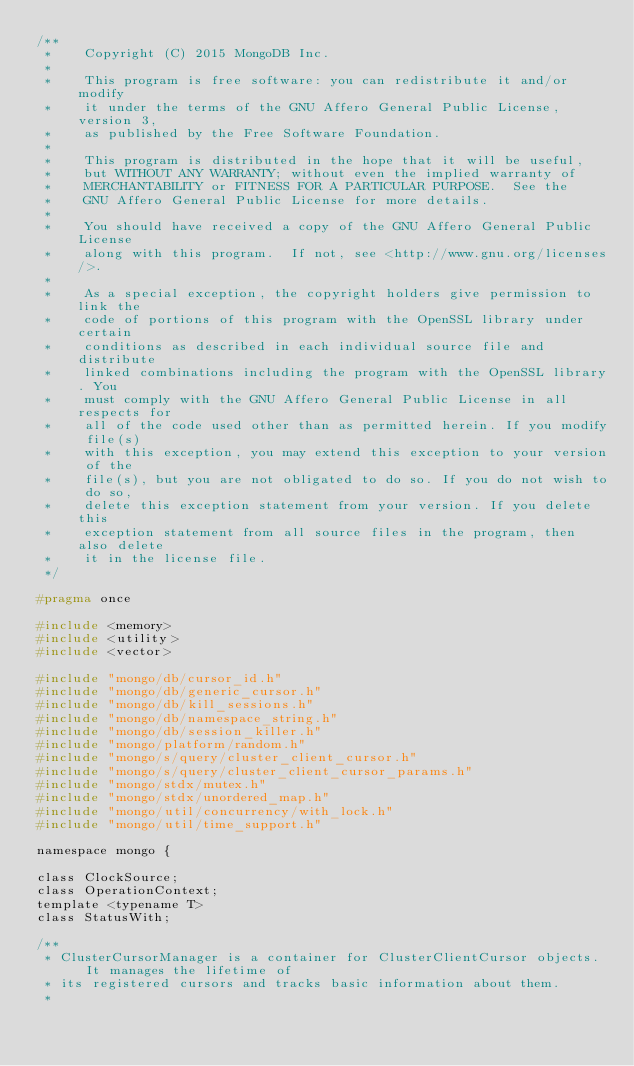Convert code to text. <code><loc_0><loc_0><loc_500><loc_500><_C_>/**
 *    Copyright (C) 2015 MongoDB Inc.
 *
 *    This program is free software: you can redistribute it and/or  modify
 *    it under the terms of the GNU Affero General Public License, version 3,
 *    as published by the Free Software Foundation.
 *
 *    This program is distributed in the hope that it will be useful,
 *    but WITHOUT ANY WARRANTY; without even the implied warranty of
 *    MERCHANTABILITY or FITNESS FOR A PARTICULAR PURPOSE.  See the
 *    GNU Affero General Public License for more details.
 *
 *    You should have received a copy of the GNU Affero General Public License
 *    along with this program.  If not, see <http://www.gnu.org/licenses/>.
 *
 *    As a special exception, the copyright holders give permission to link the
 *    code of portions of this program with the OpenSSL library under certain
 *    conditions as described in each individual source file and distribute
 *    linked combinations including the program with the OpenSSL library. You
 *    must comply with the GNU Affero General Public License in all respects for
 *    all of the code used other than as permitted herein. If you modify file(s)
 *    with this exception, you may extend this exception to your version of the
 *    file(s), but you are not obligated to do so. If you do not wish to do so,
 *    delete this exception statement from your version. If you delete this
 *    exception statement from all source files in the program, then also delete
 *    it in the license file.
 */

#pragma once

#include <memory>
#include <utility>
#include <vector>

#include "mongo/db/cursor_id.h"
#include "mongo/db/generic_cursor.h"
#include "mongo/db/kill_sessions.h"
#include "mongo/db/namespace_string.h"
#include "mongo/db/session_killer.h"
#include "mongo/platform/random.h"
#include "mongo/s/query/cluster_client_cursor.h"
#include "mongo/s/query/cluster_client_cursor_params.h"
#include "mongo/stdx/mutex.h"
#include "mongo/stdx/unordered_map.h"
#include "mongo/util/concurrency/with_lock.h"
#include "mongo/util/time_support.h"

namespace mongo {

class ClockSource;
class OperationContext;
template <typename T>
class StatusWith;

/**
 * ClusterCursorManager is a container for ClusterClientCursor objects.  It manages the lifetime of
 * its registered cursors and tracks basic information about them.
 *</code> 